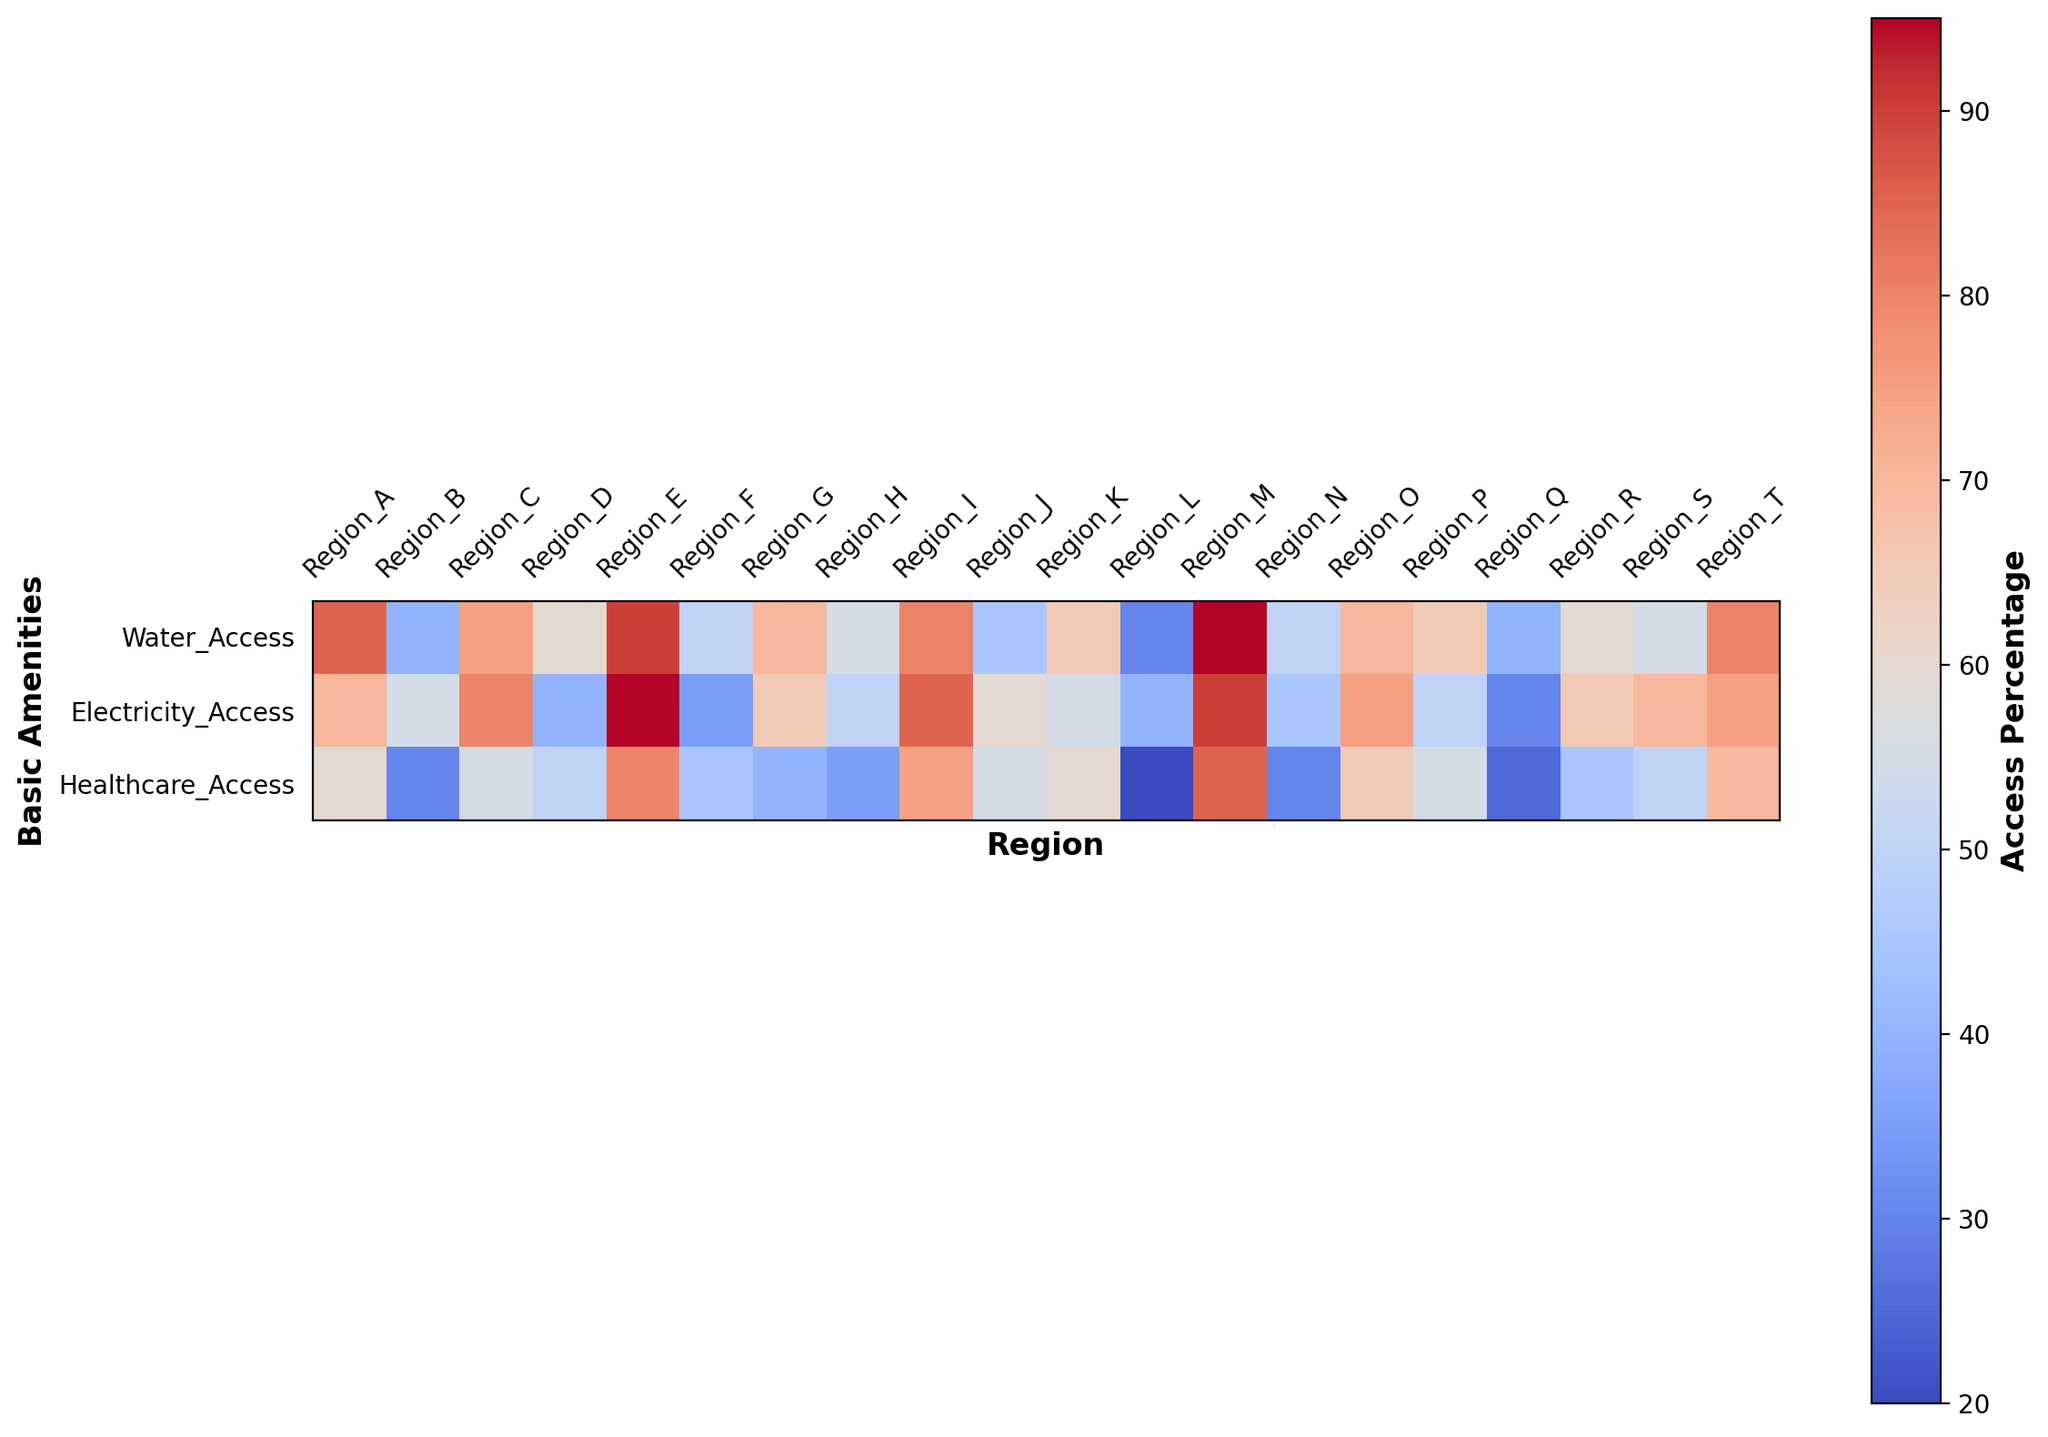Which region has the highest access to both water and healthcare amenities? Region M has the highest values for both water access (95%) and healthcare access (85%) among all regions as indicated by the deeper red color slices corresponding to these categories.
Answer: Region M Compare the water access in Region E and Region L. Which is higher, and by how much? Region E's water access is at 90%, and Region L's water access is at 30%. Subtracting the two, Region E has 60% higher water access than Region L.
Answer: Region E by 60% Which region shows the lowest level of electricity access? Region Q shows the lowest level of electricity access at 30%, indicated by the lighter color in the electricity access row for the respective column.
Answer: Region Q What is the average healthcare access percentage across all regions? Sum all the healthcare access percentages and divide by the number of regions: (60 + 30 + 55 + 50 + 80 + 45 + 40 + 35 + 75 + 55 + 60 + 20 + 85 + 30 + 65 + 55 + 25 + 45 + 50 + 70)/20 = 51.25%
Answer: 51.25% Which region has a higher access to basic amenities, Region H or Region J, based on the overall color intensity? Comparing the overall color intensity of both regions, Region J shows higher access to basic amenities than Region H due to relatively higher values of water (45%), electricity (60%), and healthcare (55%) compared to water (55%), electricity (50%), and healthcare (35%) in Region H.
Answer: Region J What is the difference in healthcare access between Region A and Region B? Healthcare access in Region A is 60%, and in Region B it is 30%. The difference is 60% - 30% = 30%.
Answer: 30% Is there a region with exactly 75% access to electricity? If so, which one? Region O and Region T both have exactly 75% access to electricity as indicated in their respective columns by the similarly moderate red color intensity in the electricity row.
Answer: Region O, Region T Identify the region with the greatest disparity between water and electricity access. What is the disparity? Region L has the greatest disparity. With water access at 30% and electricity access at 40%, the difference is 40% - 30% = 10%. No other region has a higher disparity.
Answer: 10% Compare the access to water and healthcare in Region D. Which is higher and by how much? In Region D, water access is 60%, and healthcare access is 50%. Water access is higher by 60% - 50% = 10%.
Answer: Water access by 10% Considering only water access, which regions have an access percentage above 80%? Regions A, E, I, M, and T have water access percentages above 80% as indicated by their deep red color slices in the water row.
Answer: Regions A, E, I, M, T 